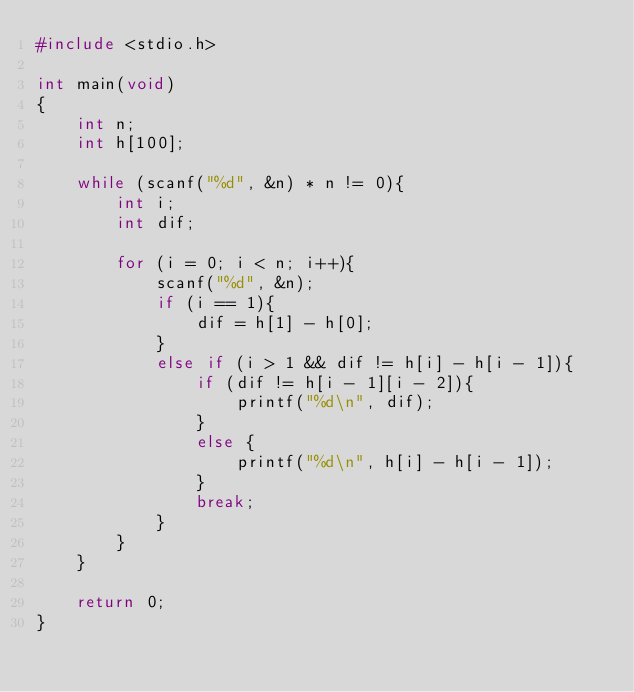Convert code to text. <code><loc_0><loc_0><loc_500><loc_500><_C_>#include <stdio.h>

int main(void)
{
	int n;
	int h[100];
	
	while (scanf("%d", &n) * n != 0){
		int i;
		int dif;
		
		for (i = 0; i < n; i++){
			scanf("%d", &n);
			if (i == 1){
				dif = h[1] - h[0];
			}
			else if (i > 1 && dif != h[i] - h[i - 1]){
				if (dif != h[i - 1][i - 2]){
					printf("%d\n", dif);
				}
				else {
					printf("%d\n", h[i] - h[i - 1]);
				}
				break;
			}
		}
	}
	
	return 0;
}</code> 